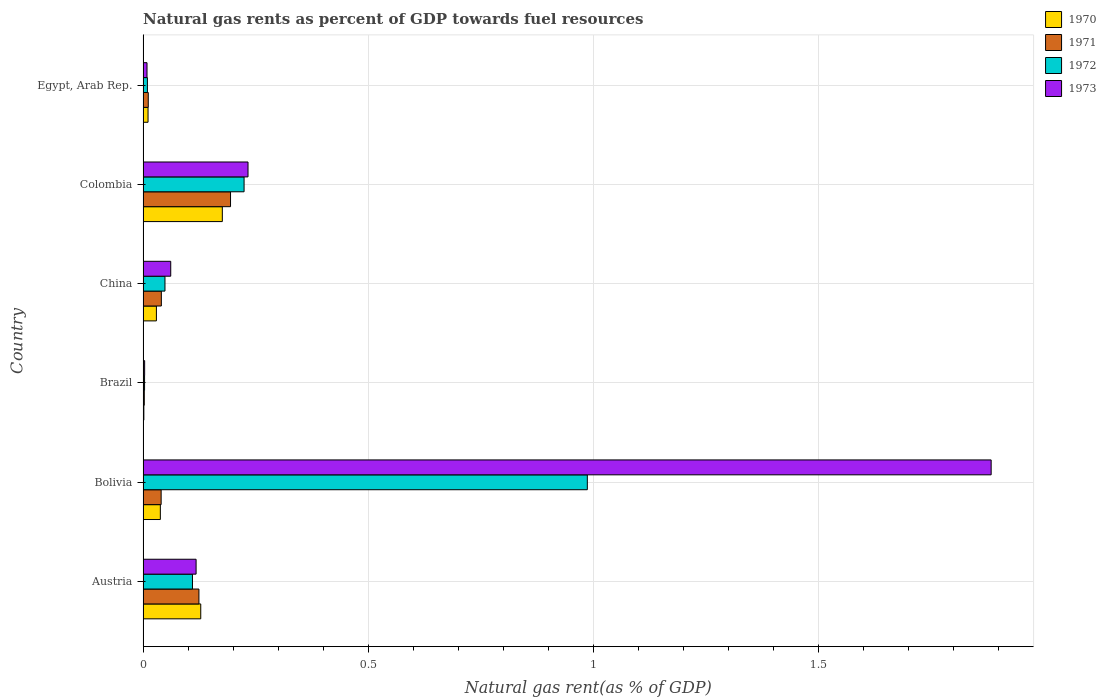Are the number of bars per tick equal to the number of legend labels?
Give a very brief answer. Yes. Are the number of bars on each tick of the Y-axis equal?
Provide a short and direct response. Yes. How many bars are there on the 2nd tick from the top?
Ensure brevity in your answer.  4. How many bars are there on the 5th tick from the bottom?
Your answer should be very brief. 4. In how many cases, is the number of bars for a given country not equal to the number of legend labels?
Your response must be concise. 0. What is the natural gas rent in 1973 in Egypt, Arab Rep.?
Ensure brevity in your answer.  0.01. Across all countries, what is the maximum natural gas rent in 1972?
Your answer should be compact. 0.99. Across all countries, what is the minimum natural gas rent in 1972?
Your answer should be compact. 0. In which country was the natural gas rent in 1971 minimum?
Keep it short and to the point. Brazil. What is the total natural gas rent in 1972 in the graph?
Make the answer very short. 1.38. What is the difference between the natural gas rent in 1972 in Bolivia and that in Brazil?
Make the answer very short. 0.98. What is the difference between the natural gas rent in 1972 in Egypt, Arab Rep. and the natural gas rent in 1971 in China?
Your answer should be very brief. -0.03. What is the average natural gas rent in 1973 per country?
Give a very brief answer. 0.38. What is the difference between the natural gas rent in 1970 and natural gas rent in 1971 in Egypt, Arab Rep.?
Offer a terse response. -0. In how many countries, is the natural gas rent in 1973 greater than 1.8 %?
Give a very brief answer. 1. What is the ratio of the natural gas rent in 1973 in Austria to that in Colombia?
Keep it short and to the point. 0.51. Is the natural gas rent in 1970 in Bolivia less than that in Brazil?
Offer a very short reply. No. What is the difference between the highest and the second highest natural gas rent in 1971?
Keep it short and to the point. 0.07. What is the difference between the highest and the lowest natural gas rent in 1972?
Offer a terse response. 0.98. Is the sum of the natural gas rent in 1972 in Brazil and China greater than the maximum natural gas rent in 1973 across all countries?
Provide a short and direct response. No. What does the 4th bar from the bottom in Austria represents?
Provide a short and direct response. 1973. How many bars are there?
Provide a short and direct response. 24. Are all the bars in the graph horizontal?
Offer a very short reply. Yes. Where does the legend appear in the graph?
Offer a terse response. Top right. How many legend labels are there?
Offer a very short reply. 4. What is the title of the graph?
Give a very brief answer. Natural gas rents as percent of GDP towards fuel resources. What is the label or title of the X-axis?
Your answer should be very brief. Natural gas rent(as % of GDP). What is the Natural gas rent(as % of GDP) in 1970 in Austria?
Keep it short and to the point. 0.13. What is the Natural gas rent(as % of GDP) of 1971 in Austria?
Your answer should be very brief. 0.12. What is the Natural gas rent(as % of GDP) in 1972 in Austria?
Give a very brief answer. 0.11. What is the Natural gas rent(as % of GDP) of 1973 in Austria?
Provide a short and direct response. 0.12. What is the Natural gas rent(as % of GDP) of 1970 in Bolivia?
Your answer should be very brief. 0.04. What is the Natural gas rent(as % of GDP) in 1971 in Bolivia?
Your response must be concise. 0.04. What is the Natural gas rent(as % of GDP) in 1972 in Bolivia?
Ensure brevity in your answer.  0.99. What is the Natural gas rent(as % of GDP) in 1973 in Bolivia?
Offer a very short reply. 1.88. What is the Natural gas rent(as % of GDP) in 1970 in Brazil?
Offer a terse response. 0. What is the Natural gas rent(as % of GDP) in 1971 in Brazil?
Give a very brief answer. 0. What is the Natural gas rent(as % of GDP) of 1972 in Brazil?
Offer a very short reply. 0. What is the Natural gas rent(as % of GDP) in 1973 in Brazil?
Keep it short and to the point. 0. What is the Natural gas rent(as % of GDP) in 1970 in China?
Ensure brevity in your answer.  0.03. What is the Natural gas rent(as % of GDP) in 1971 in China?
Your answer should be very brief. 0.04. What is the Natural gas rent(as % of GDP) in 1972 in China?
Provide a short and direct response. 0.05. What is the Natural gas rent(as % of GDP) of 1973 in China?
Make the answer very short. 0.06. What is the Natural gas rent(as % of GDP) in 1970 in Colombia?
Provide a succinct answer. 0.18. What is the Natural gas rent(as % of GDP) of 1971 in Colombia?
Provide a short and direct response. 0.19. What is the Natural gas rent(as % of GDP) in 1972 in Colombia?
Your answer should be compact. 0.22. What is the Natural gas rent(as % of GDP) of 1973 in Colombia?
Provide a short and direct response. 0.23. What is the Natural gas rent(as % of GDP) of 1970 in Egypt, Arab Rep.?
Ensure brevity in your answer.  0.01. What is the Natural gas rent(as % of GDP) of 1971 in Egypt, Arab Rep.?
Provide a succinct answer. 0.01. What is the Natural gas rent(as % of GDP) in 1972 in Egypt, Arab Rep.?
Your answer should be very brief. 0.01. What is the Natural gas rent(as % of GDP) in 1973 in Egypt, Arab Rep.?
Provide a succinct answer. 0.01. Across all countries, what is the maximum Natural gas rent(as % of GDP) in 1970?
Your answer should be very brief. 0.18. Across all countries, what is the maximum Natural gas rent(as % of GDP) in 1971?
Keep it short and to the point. 0.19. Across all countries, what is the maximum Natural gas rent(as % of GDP) of 1972?
Ensure brevity in your answer.  0.99. Across all countries, what is the maximum Natural gas rent(as % of GDP) of 1973?
Make the answer very short. 1.88. Across all countries, what is the minimum Natural gas rent(as % of GDP) in 1970?
Provide a succinct answer. 0. Across all countries, what is the minimum Natural gas rent(as % of GDP) in 1971?
Keep it short and to the point. 0. Across all countries, what is the minimum Natural gas rent(as % of GDP) of 1972?
Make the answer very short. 0. Across all countries, what is the minimum Natural gas rent(as % of GDP) in 1973?
Provide a succinct answer. 0. What is the total Natural gas rent(as % of GDP) in 1970 in the graph?
Ensure brevity in your answer.  0.38. What is the total Natural gas rent(as % of GDP) in 1971 in the graph?
Provide a short and direct response. 0.41. What is the total Natural gas rent(as % of GDP) of 1972 in the graph?
Offer a very short reply. 1.38. What is the total Natural gas rent(as % of GDP) of 1973 in the graph?
Keep it short and to the point. 2.31. What is the difference between the Natural gas rent(as % of GDP) of 1970 in Austria and that in Bolivia?
Provide a short and direct response. 0.09. What is the difference between the Natural gas rent(as % of GDP) of 1971 in Austria and that in Bolivia?
Your answer should be very brief. 0.08. What is the difference between the Natural gas rent(as % of GDP) in 1972 in Austria and that in Bolivia?
Keep it short and to the point. -0.88. What is the difference between the Natural gas rent(as % of GDP) of 1973 in Austria and that in Bolivia?
Keep it short and to the point. -1.77. What is the difference between the Natural gas rent(as % of GDP) of 1970 in Austria and that in Brazil?
Offer a terse response. 0.13. What is the difference between the Natural gas rent(as % of GDP) in 1971 in Austria and that in Brazil?
Provide a succinct answer. 0.12. What is the difference between the Natural gas rent(as % of GDP) in 1972 in Austria and that in Brazil?
Ensure brevity in your answer.  0.11. What is the difference between the Natural gas rent(as % of GDP) in 1973 in Austria and that in Brazil?
Your answer should be very brief. 0.11. What is the difference between the Natural gas rent(as % of GDP) of 1970 in Austria and that in China?
Offer a terse response. 0.1. What is the difference between the Natural gas rent(as % of GDP) in 1971 in Austria and that in China?
Provide a succinct answer. 0.08. What is the difference between the Natural gas rent(as % of GDP) in 1972 in Austria and that in China?
Offer a terse response. 0.06. What is the difference between the Natural gas rent(as % of GDP) in 1973 in Austria and that in China?
Provide a succinct answer. 0.06. What is the difference between the Natural gas rent(as % of GDP) in 1970 in Austria and that in Colombia?
Provide a short and direct response. -0.05. What is the difference between the Natural gas rent(as % of GDP) in 1971 in Austria and that in Colombia?
Provide a short and direct response. -0.07. What is the difference between the Natural gas rent(as % of GDP) in 1972 in Austria and that in Colombia?
Keep it short and to the point. -0.11. What is the difference between the Natural gas rent(as % of GDP) in 1973 in Austria and that in Colombia?
Provide a short and direct response. -0.12. What is the difference between the Natural gas rent(as % of GDP) of 1970 in Austria and that in Egypt, Arab Rep.?
Offer a very short reply. 0.12. What is the difference between the Natural gas rent(as % of GDP) in 1971 in Austria and that in Egypt, Arab Rep.?
Offer a very short reply. 0.11. What is the difference between the Natural gas rent(as % of GDP) of 1973 in Austria and that in Egypt, Arab Rep.?
Keep it short and to the point. 0.11. What is the difference between the Natural gas rent(as % of GDP) in 1970 in Bolivia and that in Brazil?
Offer a very short reply. 0.04. What is the difference between the Natural gas rent(as % of GDP) of 1971 in Bolivia and that in Brazil?
Give a very brief answer. 0.04. What is the difference between the Natural gas rent(as % of GDP) in 1972 in Bolivia and that in Brazil?
Ensure brevity in your answer.  0.98. What is the difference between the Natural gas rent(as % of GDP) of 1973 in Bolivia and that in Brazil?
Your response must be concise. 1.88. What is the difference between the Natural gas rent(as % of GDP) in 1970 in Bolivia and that in China?
Your answer should be compact. 0.01. What is the difference between the Natural gas rent(as % of GDP) in 1971 in Bolivia and that in China?
Provide a succinct answer. -0. What is the difference between the Natural gas rent(as % of GDP) in 1972 in Bolivia and that in China?
Offer a terse response. 0.94. What is the difference between the Natural gas rent(as % of GDP) of 1973 in Bolivia and that in China?
Give a very brief answer. 1.82. What is the difference between the Natural gas rent(as % of GDP) in 1970 in Bolivia and that in Colombia?
Offer a very short reply. -0.14. What is the difference between the Natural gas rent(as % of GDP) in 1971 in Bolivia and that in Colombia?
Your answer should be very brief. -0.15. What is the difference between the Natural gas rent(as % of GDP) in 1972 in Bolivia and that in Colombia?
Your answer should be compact. 0.76. What is the difference between the Natural gas rent(as % of GDP) of 1973 in Bolivia and that in Colombia?
Offer a very short reply. 1.65. What is the difference between the Natural gas rent(as % of GDP) of 1970 in Bolivia and that in Egypt, Arab Rep.?
Make the answer very short. 0.03. What is the difference between the Natural gas rent(as % of GDP) of 1971 in Bolivia and that in Egypt, Arab Rep.?
Ensure brevity in your answer.  0.03. What is the difference between the Natural gas rent(as % of GDP) of 1972 in Bolivia and that in Egypt, Arab Rep.?
Provide a succinct answer. 0.98. What is the difference between the Natural gas rent(as % of GDP) in 1973 in Bolivia and that in Egypt, Arab Rep.?
Keep it short and to the point. 1.87. What is the difference between the Natural gas rent(as % of GDP) in 1970 in Brazil and that in China?
Make the answer very short. -0.03. What is the difference between the Natural gas rent(as % of GDP) in 1971 in Brazil and that in China?
Make the answer very short. -0.04. What is the difference between the Natural gas rent(as % of GDP) of 1972 in Brazil and that in China?
Provide a succinct answer. -0.05. What is the difference between the Natural gas rent(as % of GDP) of 1973 in Brazil and that in China?
Your response must be concise. -0.06. What is the difference between the Natural gas rent(as % of GDP) of 1970 in Brazil and that in Colombia?
Provide a succinct answer. -0.17. What is the difference between the Natural gas rent(as % of GDP) of 1971 in Brazil and that in Colombia?
Provide a succinct answer. -0.19. What is the difference between the Natural gas rent(as % of GDP) of 1972 in Brazil and that in Colombia?
Ensure brevity in your answer.  -0.22. What is the difference between the Natural gas rent(as % of GDP) in 1973 in Brazil and that in Colombia?
Your answer should be compact. -0.23. What is the difference between the Natural gas rent(as % of GDP) in 1970 in Brazil and that in Egypt, Arab Rep.?
Your answer should be very brief. -0.01. What is the difference between the Natural gas rent(as % of GDP) in 1971 in Brazil and that in Egypt, Arab Rep.?
Offer a very short reply. -0.01. What is the difference between the Natural gas rent(as % of GDP) in 1972 in Brazil and that in Egypt, Arab Rep.?
Offer a very short reply. -0.01. What is the difference between the Natural gas rent(as % of GDP) in 1973 in Brazil and that in Egypt, Arab Rep.?
Your answer should be very brief. -0.01. What is the difference between the Natural gas rent(as % of GDP) in 1970 in China and that in Colombia?
Your response must be concise. -0.15. What is the difference between the Natural gas rent(as % of GDP) of 1971 in China and that in Colombia?
Offer a very short reply. -0.15. What is the difference between the Natural gas rent(as % of GDP) in 1972 in China and that in Colombia?
Give a very brief answer. -0.18. What is the difference between the Natural gas rent(as % of GDP) in 1973 in China and that in Colombia?
Ensure brevity in your answer.  -0.17. What is the difference between the Natural gas rent(as % of GDP) in 1970 in China and that in Egypt, Arab Rep.?
Your response must be concise. 0.02. What is the difference between the Natural gas rent(as % of GDP) in 1971 in China and that in Egypt, Arab Rep.?
Offer a very short reply. 0.03. What is the difference between the Natural gas rent(as % of GDP) of 1972 in China and that in Egypt, Arab Rep.?
Your answer should be very brief. 0.04. What is the difference between the Natural gas rent(as % of GDP) of 1973 in China and that in Egypt, Arab Rep.?
Give a very brief answer. 0.05. What is the difference between the Natural gas rent(as % of GDP) in 1970 in Colombia and that in Egypt, Arab Rep.?
Your response must be concise. 0.16. What is the difference between the Natural gas rent(as % of GDP) of 1971 in Colombia and that in Egypt, Arab Rep.?
Ensure brevity in your answer.  0.18. What is the difference between the Natural gas rent(as % of GDP) in 1972 in Colombia and that in Egypt, Arab Rep.?
Your answer should be compact. 0.21. What is the difference between the Natural gas rent(as % of GDP) of 1973 in Colombia and that in Egypt, Arab Rep.?
Ensure brevity in your answer.  0.22. What is the difference between the Natural gas rent(as % of GDP) in 1970 in Austria and the Natural gas rent(as % of GDP) in 1971 in Bolivia?
Your answer should be very brief. 0.09. What is the difference between the Natural gas rent(as % of GDP) in 1970 in Austria and the Natural gas rent(as % of GDP) in 1972 in Bolivia?
Provide a short and direct response. -0.86. What is the difference between the Natural gas rent(as % of GDP) of 1970 in Austria and the Natural gas rent(as % of GDP) of 1973 in Bolivia?
Give a very brief answer. -1.75. What is the difference between the Natural gas rent(as % of GDP) of 1971 in Austria and the Natural gas rent(as % of GDP) of 1972 in Bolivia?
Give a very brief answer. -0.86. What is the difference between the Natural gas rent(as % of GDP) of 1971 in Austria and the Natural gas rent(as % of GDP) of 1973 in Bolivia?
Provide a short and direct response. -1.76. What is the difference between the Natural gas rent(as % of GDP) of 1972 in Austria and the Natural gas rent(as % of GDP) of 1973 in Bolivia?
Make the answer very short. -1.77. What is the difference between the Natural gas rent(as % of GDP) of 1970 in Austria and the Natural gas rent(as % of GDP) of 1971 in Brazil?
Offer a terse response. 0.13. What is the difference between the Natural gas rent(as % of GDP) of 1970 in Austria and the Natural gas rent(as % of GDP) of 1972 in Brazil?
Offer a terse response. 0.12. What is the difference between the Natural gas rent(as % of GDP) of 1970 in Austria and the Natural gas rent(as % of GDP) of 1973 in Brazil?
Ensure brevity in your answer.  0.12. What is the difference between the Natural gas rent(as % of GDP) in 1971 in Austria and the Natural gas rent(as % of GDP) in 1972 in Brazil?
Your response must be concise. 0.12. What is the difference between the Natural gas rent(as % of GDP) of 1971 in Austria and the Natural gas rent(as % of GDP) of 1973 in Brazil?
Your response must be concise. 0.12. What is the difference between the Natural gas rent(as % of GDP) of 1972 in Austria and the Natural gas rent(as % of GDP) of 1973 in Brazil?
Make the answer very short. 0.11. What is the difference between the Natural gas rent(as % of GDP) of 1970 in Austria and the Natural gas rent(as % of GDP) of 1971 in China?
Provide a succinct answer. 0.09. What is the difference between the Natural gas rent(as % of GDP) of 1970 in Austria and the Natural gas rent(as % of GDP) of 1972 in China?
Give a very brief answer. 0.08. What is the difference between the Natural gas rent(as % of GDP) of 1970 in Austria and the Natural gas rent(as % of GDP) of 1973 in China?
Offer a terse response. 0.07. What is the difference between the Natural gas rent(as % of GDP) of 1971 in Austria and the Natural gas rent(as % of GDP) of 1972 in China?
Your response must be concise. 0.08. What is the difference between the Natural gas rent(as % of GDP) in 1971 in Austria and the Natural gas rent(as % of GDP) in 1973 in China?
Provide a succinct answer. 0.06. What is the difference between the Natural gas rent(as % of GDP) in 1972 in Austria and the Natural gas rent(as % of GDP) in 1973 in China?
Ensure brevity in your answer.  0.05. What is the difference between the Natural gas rent(as % of GDP) in 1970 in Austria and the Natural gas rent(as % of GDP) in 1971 in Colombia?
Ensure brevity in your answer.  -0.07. What is the difference between the Natural gas rent(as % of GDP) in 1970 in Austria and the Natural gas rent(as % of GDP) in 1972 in Colombia?
Offer a terse response. -0.1. What is the difference between the Natural gas rent(as % of GDP) in 1970 in Austria and the Natural gas rent(as % of GDP) in 1973 in Colombia?
Provide a succinct answer. -0.1. What is the difference between the Natural gas rent(as % of GDP) of 1971 in Austria and the Natural gas rent(as % of GDP) of 1972 in Colombia?
Provide a short and direct response. -0.1. What is the difference between the Natural gas rent(as % of GDP) in 1971 in Austria and the Natural gas rent(as % of GDP) in 1973 in Colombia?
Give a very brief answer. -0.11. What is the difference between the Natural gas rent(as % of GDP) in 1972 in Austria and the Natural gas rent(as % of GDP) in 1973 in Colombia?
Provide a succinct answer. -0.12. What is the difference between the Natural gas rent(as % of GDP) of 1970 in Austria and the Natural gas rent(as % of GDP) of 1971 in Egypt, Arab Rep.?
Offer a terse response. 0.12. What is the difference between the Natural gas rent(as % of GDP) of 1970 in Austria and the Natural gas rent(as % of GDP) of 1972 in Egypt, Arab Rep.?
Your response must be concise. 0.12. What is the difference between the Natural gas rent(as % of GDP) in 1970 in Austria and the Natural gas rent(as % of GDP) in 1973 in Egypt, Arab Rep.?
Your response must be concise. 0.12. What is the difference between the Natural gas rent(as % of GDP) of 1971 in Austria and the Natural gas rent(as % of GDP) of 1972 in Egypt, Arab Rep.?
Your answer should be compact. 0.11. What is the difference between the Natural gas rent(as % of GDP) in 1971 in Austria and the Natural gas rent(as % of GDP) in 1973 in Egypt, Arab Rep.?
Ensure brevity in your answer.  0.12. What is the difference between the Natural gas rent(as % of GDP) in 1972 in Austria and the Natural gas rent(as % of GDP) in 1973 in Egypt, Arab Rep.?
Keep it short and to the point. 0.1. What is the difference between the Natural gas rent(as % of GDP) in 1970 in Bolivia and the Natural gas rent(as % of GDP) in 1971 in Brazil?
Make the answer very short. 0.04. What is the difference between the Natural gas rent(as % of GDP) in 1970 in Bolivia and the Natural gas rent(as % of GDP) in 1972 in Brazil?
Provide a succinct answer. 0.04. What is the difference between the Natural gas rent(as % of GDP) in 1970 in Bolivia and the Natural gas rent(as % of GDP) in 1973 in Brazil?
Offer a very short reply. 0.03. What is the difference between the Natural gas rent(as % of GDP) of 1971 in Bolivia and the Natural gas rent(as % of GDP) of 1972 in Brazil?
Offer a very short reply. 0.04. What is the difference between the Natural gas rent(as % of GDP) in 1971 in Bolivia and the Natural gas rent(as % of GDP) in 1973 in Brazil?
Provide a short and direct response. 0.04. What is the difference between the Natural gas rent(as % of GDP) in 1972 in Bolivia and the Natural gas rent(as % of GDP) in 1973 in Brazil?
Ensure brevity in your answer.  0.98. What is the difference between the Natural gas rent(as % of GDP) of 1970 in Bolivia and the Natural gas rent(as % of GDP) of 1971 in China?
Offer a terse response. -0. What is the difference between the Natural gas rent(as % of GDP) in 1970 in Bolivia and the Natural gas rent(as % of GDP) in 1972 in China?
Your answer should be very brief. -0.01. What is the difference between the Natural gas rent(as % of GDP) of 1970 in Bolivia and the Natural gas rent(as % of GDP) of 1973 in China?
Your answer should be very brief. -0.02. What is the difference between the Natural gas rent(as % of GDP) of 1971 in Bolivia and the Natural gas rent(as % of GDP) of 1972 in China?
Give a very brief answer. -0.01. What is the difference between the Natural gas rent(as % of GDP) in 1971 in Bolivia and the Natural gas rent(as % of GDP) in 1973 in China?
Offer a very short reply. -0.02. What is the difference between the Natural gas rent(as % of GDP) in 1972 in Bolivia and the Natural gas rent(as % of GDP) in 1973 in China?
Your answer should be very brief. 0.92. What is the difference between the Natural gas rent(as % of GDP) in 1970 in Bolivia and the Natural gas rent(as % of GDP) in 1971 in Colombia?
Provide a short and direct response. -0.16. What is the difference between the Natural gas rent(as % of GDP) in 1970 in Bolivia and the Natural gas rent(as % of GDP) in 1972 in Colombia?
Your answer should be very brief. -0.19. What is the difference between the Natural gas rent(as % of GDP) in 1970 in Bolivia and the Natural gas rent(as % of GDP) in 1973 in Colombia?
Your response must be concise. -0.19. What is the difference between the Natural gas rent(as % of GDP) in 1971 in Bolivia and the Natural gas rent(as % of GDP) in 1972 in Colombia?
Provide a short and direct response. -0.18. What is the difference between the Natural gas rent(as % of GDP) in 1971 in Bolivia and the Natural gas rent(as % of GDP) in 1973 in Colombia?
Provide a short and direct response. -0.19. What is the difference between the Natural gas rent(as % of GDP) of 1972 in Bolivia and the Natural gas rent(as % of GDP) of 1973 in Colombia?
Keep it short and to the point. 0.75. What is the difference between the Natural gas rent(as % of GDP) in 1970 in Bolivia and the Natural gas rent(as % of GDP) in 1971 in Egypt, Arab Rep.?
Offer a very short reply. 0.03. What is the difference between the Natural gas rent(as % of GDP) in 1970 in Bolivia and the Natural gas rent(as % of GDP) in 1972 in Egypt, Arab Rep.?
Provide a short and direct response. 0.03. What is the difference between the Natural gas rent(as % of GDP) in 1970 in Bolivia and the Natural gas rent(as % of GDP) in 1973 in Egypt, Arab Rep.?
Your answer should be compact. 0.03. What is the difference between the Natural gas rent(as % of GDP) of 1971 in Bolivia and the Natural gas rent(as % of GDP) of 1972 in Egypt, Arab Rep.?
Offer a very short reply. 0.03. What is the difference between the Natural gas rent(as % of GDP) of 1971 in Bolivia and the Natural gas rent(as % of GDP) of 1973 in Egypt, Arab Rep.?
Keep it short and to the point. 0.03. What is the difference between the Natural gas rent(as % of GDP) in 1972 in Bolivia and the Natural gas rent(as % of GDP) in 1973 in Egypt, Arab Rep.?
Provide a succinct answer. 0.98. What is the difference between the Natural gas rent(as % of GDP) of 1970 in Brazil and the Natural gas rent(as % of GDP) of 1971 in China?
Your response must be concise. -0.04. What is the difference between the Natural gas rent(as % of GDP) of 1970 in Brazil and the Natural gas rent(as % of GDP) of 1972 in China?
Offer a very short reply. -0.05. What is the difference between the Natural gas rent(as % of GDP) in 1970 in Brazil and the Natural gas rent(as % of GDP) in 1973 in China?
Keep it short and to the point. -0.06. What is the difference between the Natural gas rent(as % of GDP) of 1971 in Brazil and the Natural gas rent(as % of GDP) of 1972 in China?
Your answer should be very brief. -0.05. What is the difference between the Natural gas rent(as % of GDP) of 1971 in Brazil and the Natural gas rent(as % of GDP) of 1973 in China?
Give a very brief answer. -0.06. What is the difference between the Natural gas rent(as % of GDP) in 1972 in Brazil and the Natural gas rent(as % of GDP) in 1973 in China?
Your answer should be compact. -0.06. What is the difference between the Natural gas rent(as % of GDP) of 1970 in Brazil and the Natural gas rent(as % of GDP) of 1971 in Colombia?
Provide a short and direct response. -0.19. What is the difference between the Natural gas rent(as % of GDP) in 1970 in Brazil and the Natural gas rent(as % of GDP) in 1972 in Colombia?
Provide a short and direct response. -0.22. What is the difference between the Natural gas rent(as % of GDP) of 1970 in Brazil and the Natural gas rent(as % of GDP) of 1973 in Colombia?
Your answer should be compact. -0.23. What is the difference between the Natural gas rent(as % of GDP) in 1971 in Brazil and the Natural gas rent(as % of GDP) in 1972 in Colombia?
Offer a very short reply. -0.22. What is the difference between the Natural gas rent(as % of GDP) in 1971 in Brazil and the Natural gas rent(as % of GDP) in 1973 in Colombia?
Keep it short and to the point. -0.23. What is the difference between the Natural gas rent(as % of GDP) in 1972 in Brazil and the Natural gas rent(as % of GDP) in 1973 in Colombia?
Your response must be concise. -0.23. What is the difference between the Natural gas rent(as % of GDP) in 1970 in Brazil and the Natural gas rent(as % of GDP) in 1971 in Egypt, Arab Rep.?
Offer a very short reply. -0.01. What is the difference between the Natural gas rent(as % of GDP) in 1970 in Brazil and the Natural gas rent(as % of GDP) in 1972 in Egypt, Arab Rep.?
Keep it short and to the point. -0.01. What is the difference between the Natural gas rent(as % of GDP) of 1970 in Brazil and the Natural gas rent(as % of GDP) of 1973 in Egypt, Arab Rep.?
Provide a short and direct response. -0.01. What is the difference between the Natural gas rent(as % of GDP) of 1971 in Brazil and the Natural gas rent(as % of GDP) of 1972 in Egypt, Arab Rep.?
Your response must be concise. -0.01. What is the difference between the Natural gas rent(as % of GDP) of 1971 in Brazil and the Natural gas rent(as % of GDP) of 1973 in Egypt, Arab Rep.?
Give a very brief answer. -0.01. What is the difference between the Natural gas rent(as % of GDP) of 1972 in Brazil and the Natural gas rent(as % of GDP) of 1973 in Egypt, Arab Rep.?
Keep it short and to the point. -0.01. What is the difference between the Natural gas rent(as % of GDP) of 1970 in China and the Natural gas rent(as % of GDP) of 1971 in Colombia?
Offer a terse response. -0.16. What is the difference between the Natural gas rent(as % of GDP) of 1970 in China and the Natural gas rent(as % of GDP) of 1972 in Colombia?
Ensure brevity in your answer.  -0.19. What is the difference between the Natural gas rent(as % of GDP) of 1970 in China and the Natural gas rent(as % of GDP) of 1973 in Colombia?
Offer a terse response. -0.2. What is the difference between the Natural gas rent(as % of GDP) of 1971 in China and the Natural gas rent(as % of GDP) of 1972 in Colombia?
Offer a terse response. -0.18. What is the difference between the Natural gas rent(as % of GDP) in 1971 in China and the Natural gas rent(as % of GDP) in 1973 in Colombia?
Give a very brief answer. -0.19. What is the difference between the Natural gas rent(as % of GDP) of 1972 in China and the Natural gas rent(as % of GDP) of 1973 in Colombia?
Make the answer very short. -0.18. What is the difference between the Natural gas rent(as % of GDP) of 1970 in China and the Natural gas rent(as % of GDP) of 1971 in Egypt, Arab Rep.?
Give a very brief answer. 0.02. What is the difference between the Natural gas rent(as % of GDP) in 1970 in China and the Natural gas rent(as % of GDP) in 1972 in Egypt, Arab Rep.?
Offer a very short reply. 0.02. What is the difference between the Natural gas rent(as % of GDP) of 1970 in China and the Natural gas rent(as % of GDP) of 1973 in Egypt, Arab Rep.?
Make the answer very short. 0.02. What is the difference between the Natural gas rent(as % of GDP) of 1971 in China and the Natural gas rent(as % of GDP) of 1972 in Egypt, Arab Rep.?
Ensure brevity in your answer.  0.03. What is the difference between the Natural gas rent(as % of GDP) of 1971 in China and the Natural gas rent(as % of GDP) of 1973 in Egypt, Arab Rep.?
Offer a very short reply. 0.03. What is the difference between the Natural gas rent(as % of GDP) in 1972 in China and the Natural gas rent(as % of GDP) in 1973 in Egypt, Arab Rep.?
Offer a very short reply. 0.04. What is the difference between the Natural gas rent(as % of GDP) in 1970 in Colombia and the Natural gas rent(as % of GDP) in 1971 in Egypt, Arab Rep.?
Offer a terse response. 0.16. What is the difference between the Natural gas rent(as % of GDP) in 1970 in Colombia and the Natural gas rent(as % of GDP) in 1972 in Egypt, Arab Rep.?
Give a very brief answer. 0.17. What is the difference between the Natural gas rent(as % of GDP) of 1970 in Colombia and the Natural gas rent(as % of GDP) of 1973 in Egypt, Arab Rep.?
Your response must be concise. 0.17. What is the difference between the Natural gas rent(as % of GDP) of 1971 in Colombia and the Natural gas rent(as % of GDP) of 1972 in Egypt, Arab Rep.?
Provide a succinct answer. 0.18. What is the difference between the Natural gas rent(as % of GDP) of 1971 in Colombia and the Natural gas rent(as % of GDP) of 1973 in Egypt, Arab Rep.?
Provide a short and direct response. 0.19. What is the difference between the Natural gas rent(as % of GDP) in 1972 in Colombia and the Natural gas rent(as % of GDP) in 1973 in Egypt, Arab Rep.?
Your response must be concise. 0.22. What is the average Natural gas rent(as % of GDP) in 1970 per country?
Keep it short and to the point. 0.06. What is the average Natural gas rent(as % of GDP) in 1971 per country?
Ensure brevity in your answer.  0.07. What is the average Natural gas rent(as % of GDP) of 1972 per country?
Offer a very short reply. 0.23. What is the average Natural gas rent(as % of GDP) of 1973 per country?
Your answer should be very brief. 0.38. What is the difference between the Natural gas rent(as % of GDP) of 1970 and Natural gas rent(as % of GDP) of 1971 in Austria?
Offer a terse response. 0. What is the difference between the Natural gas rent(as % of GDP) in 1970 and Natural gas rent(as % of GDP) in 1972 in Austria?
Your answer should be compact. 0.02. What is the difference between the Natural gas rent(as % of GDP) of 1970 and Natural gas rent(as % of GDP) of 1973 in Austria?
Make the answer very short. 0.01. What is the difference between the Natural gas rent(as % of GDP) of 1971 and Natural gas rent(as % of GDP) of 1972 in Austria?
Provide a succinct answer. 0.01. What is the difference between the Natural gas rent(as % of GDP) of 1971 and Natural gas rent(as % of GDP) of 1973 in Austria?
Ensure brevity in your answer.  0.01. What is the difference between the Natural gas rent(as % of GDP) in 1972 and Natural gas rent(as % of GDP) in 1973 in Austria?
Provide a succinct answer. -0.01. What is the difference between the Natural gas rent(as % of GDP) in 1970 and Natural gas rent(as % of GDP) in 1971 in Bolivia?
Offer a very short reply. -0. What is the difference between the Natural gas rent(as % of GDP) in 1970 and Natural gas rent(as % of GDP) in 1972 in Bolivia?
Your response must be concise. -0.95. What is the difference between the Natural gas rent(as % of GDP) in 1970 and Natural gas rent(as % of GDP) in 1973 in Bolivia?
Offer a very short reply. -1.84. What is the difference between the Natural gas rent(as % of GDP) in 1971 and Natural gas rent(as % of GDP) in 1972 in Bolivia?
Provide a short and direct response. -0.95. What is the difference between the Natural gas rent(as % of GDP) of 1971 and Natural gas rent(as % of GDP) of 1973 in Bolivia?
Ensure brevity in your answer.  -1.84. What is the difference between the Natural gas rent(as % of GDP) of 1972 and Natural gas rent(as % of GDP) of 1973 in Bolivia?
Ensure brevity in your answer.  -0.9. What is the difference between the Natural gas rent(as % of GDP) in 1970 and Natural gas rent(as % of GDP) in 1971 in Brazil?
Provide a succinct answer. -0. What is the difference between the Natural gas rent(as % of GDP) in 1970 and Natural gas rent(as % of GDP) in 1972 in Brazil?
Give a very brief answer. -0. What is the difference between the Natural gas rent(as % of GDP) of 1970 and Natural gas rent(as % of GDP) of 1973 in Brazil?
Your answer should be very brief. -0. What is the difference between the Natural gas rent(as % of GDP) of 1971 and Natural gas rent(as % of GDP) of 1972 in Brazil?
Your response must be concise. -0. What is the difference between the Natural gas rent(as % of GDP) in 1971 and Natural gas rent(as % of GDP) in 1973 in Brazil?
Make the answer very short. -0. What is the difference between the Natural gas rent(as % of GDP) of 1972 and Natural gas rent(as % of GDP) of 1973 in Brazil?
Ensure brevity in your answer.  -0. What is the difference between the Natural gas rent(as % of GDP) of 1970 and Natural gas rent(as % of GDP) of 1971 in China?
Offer a very short reply. -0.01. What is the difference between the Natural gas rent(as % of GDP) of 1970 and Natural gas rent(as % of GDP) of 1972 in China?
Provide a succinct answer. -0.02. What is the difference between the Natural gas rent(as % of GDP) of 1970 and Natural gas rent(as % of GDP) of 1973 in China?
Your answer should be very brief. -0.03. What is the difference between the Natural gas rent(as % of GDP) of 1971 and Natural gas rent(as % of GDP) of 1972 in China?
Offer a very short reply. -0.01. What is the difference between the Natural gas rent(as % of GDP) of 1971 and Natural gas rent(as % of GDP) of 1973 in China?
Ensure brevity in your answer.  -0.02. What is the difference between the Natural gas rent(as % of GDP) of 1972 and Natural gas rent(as % of GDP) of 1973 in China?
Offer a terse response. -0.01. What is the difference between the Natural gas rent(as % of GDP) of 1970 and Natural gas rent(as % of GDP) of 1971 in Colombia?
Give a very brief answer. -0.02. What is the difference between the Natural gas rent(as % of GDP) of 1970 and Natural gas rent(as % of GDP) of 1972 in Colombia?
Give a very brief answer. -0.05. What is the difference between the Natural gas rent(as % of GDP) of 1970 and Natural gas rent(as % of GDP) of 1973 in Colombia?
Make the answer very short. -0.06. What is the difference between the Natural gas rent(as % of GDP) of 1971 and Natural gas rent(as % of GDP) of 1972 in Colombia?
Give a very brief answer. -0.03. What is the difference between the Natural gas rent(as % of GDP) of 1971 and Natural gas rent(as % of GDP) of 1973 in Colombia?
Offer a very short reply. -0.04. What is the difference between the Natural gas rent(as % of GDP) in 1972 and Natural gas rent(as % of GDP) in 1973 in Colombia?
Keep it short and to the point. -0.01. What is the difference between the Natural gas rent(as % of GDP) in 1970 and Natural gas rent(as % of GDP) in 1971 in Egypt, Arab Rep.?
Give a very brief answer. -0. What is the difference between the Natural gas rent(as % of GDP) in 1970 and Natural gas rent(as % of GDP) in 1972 in Egypt, Arab Rep.?
Your answer should be very brief. 0. What is the difference between the Natural gas rent(as % of GDP) in 1970 and Natural gas rent(as % of GDP) in 1973 in Egypt, Arab Rep.?
Your response must be concise. 0. What is the difference between the Natural gas rent(as % of GDP) in 1971 and Natural gas rent(as % of GDP) in 1972 in Egypt, Arab Rep.?
Keep it short and to the point. 0. What is the difference between the Natural gas rent(as % of GDP) in 1971 and Natural gas rent(as % of GDP) in 1973 in Egypt, Arab Rep.?
Provide a succinct answer. 0. What is the difference between the Natural gas rent(as % of GDP) in 1972 and Natural gas rent(as % of GDP) in 1973 in Egypt, Arab Rep.?
Give a very brief answer. 0. What is the ratio of the Natural gas rent(as % of GDP) in 1970 in Austria to that in Bolivia?
Ensure brevity in your answer.  3.34. What is the ratio of the Natural gas rent(as % of GDP) of 1971 in Austria to that in Bolivia?
Your answer should be very brief. 3.09. What is the ratio of the Natural gas rent(as % of GDP) in 1972 in Austria to that in Bolivia?
Your response must be concise. 0.11. What is the ratio of the Natural gas rent(as % of GDP) in 1973 in Austria to that in Bolivia?
Your answer should be compact. 0.06. What is the ratio of the Natural gas rent(as % of GDP) of 1970 in Austria to that in Brazil?
Offer a very short reply. 72. What is the ratio of the Natural gas rent(as % of GDP) of 1971 in Austria to that in Brazil?
Your response must be concise. 45.2. What is the ratio of the Natural gas rent(as % of GDP) in 1972 in Austria to that in Brazil?
Give a very brief answer. 33.07. What is the ratio of the Natural gas rent(as % of GDP) of 1973 in Austria to that in Brazil?
Your answer should be compact. 33.74. What is the ratio of the Natural gas rent(as % of GDP) of 1970 in Austria to that in China?
Offer a very short reply. 4.32. What is the ratio of the Natural gas rent(as % of GDP) of 1971 in Austria to that in China?
Your response must be concise. 3.06. What is the ratio of the Natural gas rent(as % of GDP) of 1972 in Austria to that in China?
Offer a terse response. 2.25. What is the ratio of the Natural gas rent(as % of GDP) of 1973 in Austria to that in China?
Provide a succinct answer. 1.92. What is the ratio of the Natural gas rent(as % of GDP) of 1970 in Austria to that in Colombia?
Make the answer very short. 0.73. What is the ratio of the Natural gas rent(as % of GDP) of 1971 in Austria to that in Colombia?
Make the answer very short. 0.64. What is the ratio of the Natural gas rent(as % of GDP) of 1972 in Austria to that in Colombia?
Give a very brief answer. 0.49. What is the ratio of the Natural gas rent(as % of GDP) in 1973 in Austria to that in Colombia?
Your answer should be compact. 0.51. What is the ratio of the Natural gas rent(as % of GDP) of 1970 in Austria to that in Egypt, Arab Rep.?
Ensure brevity in your answer.  11.57. What is the ratio of the Natural gas rent(as % of GDP) in 1971 in Austria to that in Egypt, Arab Rep.?
Your response must be concise. 10.75. What is the ratio of the Natural gas rent(as % of GDP) of 1972 in Austria to that in Egypt, Arab Rep.?
Provide a short and direct response. 11.37. What is the ratio of the Natural gas rent(as % of GDP) in 1973 in Austria to that in Egypt, Arab Rep.?
Offer a terse response. 13.44. What is the ratio of the Natural gas rent(as % of GDP) of 1970 in Bolivia to that in Brazil?
Make the answer very short. 21.58. What is the ratio of the Natural gas rent(as % of GDP) in 1971 in Bolivia to that in Brazil?
Provide a short and direct response. 14.62. What is the ratio of the Natural gas rent(as % of GDP) in 1972 in Bolivia to that in Brazil?
Provide a short and direct response. 297.41. What is the ratio of the Natural gas rent(as % of GDP) in 1973 in Bolivia to that in Brazil?
Keep it short and to the point. 539.46. What is the ratio of the Natural gas rent(as % of GDP) in 1970 in Bolivia to that in China?
Offer a very short reply. 1.3. What is the ratio of the Natural gas rent(as % of GDP) in 1972 in Bolivia to that in China?
Offer a very short reply. 20.28. What is the ratio of the Natural gas rent(as % of GDP) in 1973 in Bolivia to that in China?
Provide a succinct answer. 30.65. What is the ratio of the Natural gas rent(as % of GDP) of 1970 in Bolivia to that in Colombia?
Provide a short and direct response. 0.22. What is the ratio of the Natural gas rent(as % of GDP) of 1971 in Bolivia to that in Colombia?
Your response must be concise. 0.21. What is the ratio of the Natural gas rent(as % of GDP) in 1972 in Bolivia to that in Colombia?
Your answer should be very brief. 4.4. What is the ratio of the Natural gas rent(as % of GDP) of 1973 in Bolivia to that in Colombia?
Keep it short and to the point. 8.08. What is the ratio of the Natural gas rent(as % of GDP) in 1970 in Bolivia to that in Egypt, Arab Rep.?
Keep it short and to the point. 3.47. What is the ratio of the Natural gas rent(as % of GDP) in 1971 in Bolivia to that in Egypt, Arab Rep.?
Provide a short and direct response. 3.48. What is the ratio of the Natural gas rent(as % of GDP) of 1972 in Bolivia to that in Egypt, Arab Rep.?
Give a very brief answer. 102.27. What is the ratio of the Natural gas rent(as % of GDP) of 1973 in Bolivia to that in Egypt, Arab Rep.?
Ensure brevity in your answer.  214.93. What is the ratio of the Natural gas rent(as % of GDP) of 1971 in Brazil to that in China?
Keep it short and to the point. 0.07. What is the ratio of the Natural gas rent(as % of GDP) in 1972 in Brazil to that in China?
Your response must be concise. 0.07. What is the ratio of the Natural gas rent(as % of GDP) in 1973 in Brazil to that in China?
Your answer should be compact. 0.06. What is the ratio of the Natural gas rent(as % of GDP) of 1970 in Brazil to that in Colombia?
Offer a very short reply. 0.01. What is the ratio of the Natural gas rent(as % of GDP) in 1971 in Brazil to that in Colombia?
Give a very brief answer. 0.01. What is the ratio of the Natural gas rent(as % of GDP) in 1972 in Brazil to that in Colombia?
Offer a terse response. 0.01. What is the ratio of the Natural gas rent(as % of GDP) in 1973 in Brazil to that in Colombia?
Offer a terse response. 0.01. What is the ratio of the Natural gas rent(as % of GDP) of 1970 in Brazil to that in Egypt, Arab Rep.?
Your answer should be very brief. 0.16. What is the ratio of the Natural gas rent(as % of GDP) in 1971 in Brazil to that in Egypt, Arab Rep.?
Your response must be concise. 0.24. What is the ratio of the Natural gas rent(as % of GDP) in 1972 in Brazil to that in Egypt, Arab Rep.?
Your answer should be compact. 0.34. What is the ratio of the Natural gas rent(as % of GDP) in 1973 in Brazil to that in Egypt, Arab Rep.?
Your answer should be compact. 0.4. What is the ratio of the Natural gas rent(as % of GDP) in 1970 in China to that in Colombia?
Make the answer very short. 0.17. What is the ratio of the Natural gas rent(as % of GDP) of 1971 in China to that in Colombia?
Offer a terse response. 0.21. What is the ratio of the Natural gas rent(as % of GDP) of 1972 in China to that in Colombia?
Give a very brief answer. 0.22. What is the ratio of the Natural gas rent(as % of GDP) of 1973 in China to that in Colombia?
Offer a very short reply. 0.26. What is the ratio of the Natural gas rent(as % of GDP) of 1970 in China to that in Egypt, Arab Rep.?
Offer a very short reply. 2.68. What is the ratio of the Natural gas rent(as % of GDP) in 1971 in China to that in Egypt, Arab Rep.?
Keep it short and to the point. 3.52. What is the ratio of the Natural gas rent(as % of GDP) in 1972 in China to that in Egypt, Arab Rep.?
Ensure brevity in your answer.  5.04. What is the ratio of the Natural gas rent(as % of GDP) in 1973 in China to that in Egypt, Arab Rep.?
Provide a short and direct response. 7.01. What is the ratio of the Natural gas rent(as % of GDP) in 1970 in Colombia to that in Egypt, Arab Rep.?
Your answer should be very brief. 15.9. What is the ratio of the Natural gas rent(as % of GDP) of 1971 in Colombia to that in Egypt, Arab Rep.?
Your response must be concise. 16.84. What is the ratio of the Natural gas rent(as % of GDP) in 1972 in Colombia to that in Egypt, Arab Rep.?
Give a very brief answer. 23.25. What is the ratio of the Natural gas rent(as % of GDP) of 1973 in Colombia to that in Egypt, Arab Rep.?
Offer a very short reply. 26.6. What is the difference between the highest and the second highest Natural gas rent(as % of GDP) of 1970?
Make the answer very short. 0.05. What is the difference between the highest and the second highest Natural gas rent(as % of GDP) in 1971?
Offer a terse response. 0.07. What is the difference between the highest and the second highest Natural gas rent(as % of GDP) of 1972?
Make the answer very short. 0.76. What is the difference between the highest and the second highest Natural gas rent(as % of GDP) of 1973?
Your answer should be very brief. 1.65. What is the difference between the highest and the lowest Natural gas rent(as % of GDP) in 1970?
Ensure brevity in your answer.  0.17. What is the difference between the highest and the lowest Natural gas rent(as % of GDP) of 1971?
Your answer should be very brief. 0.19. What is the difference between the highest and the lowest Natural gas rent(as % of GDP) in 1973?
Your response must be concise. 1.88. 